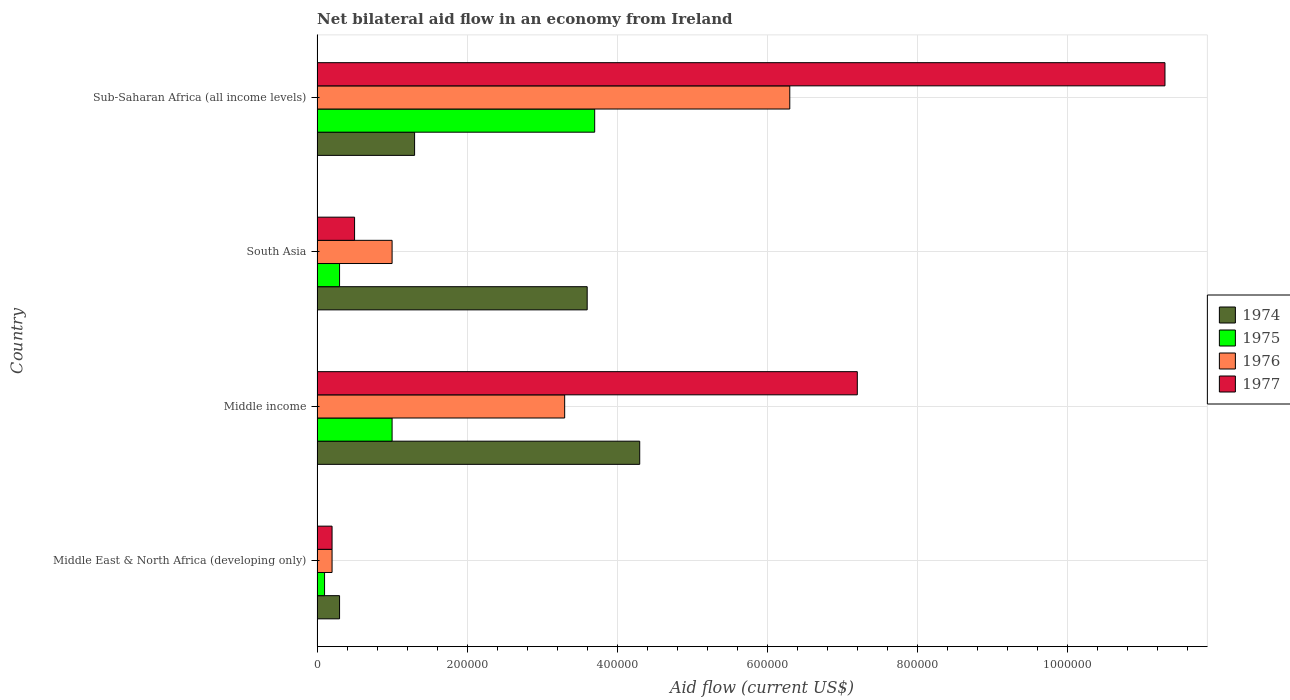How many different coloured bars are there?
Ensure brevity in your answer.  4. Are the number of bars per tick equal to the number of legend labels?
Your answer should be very brief. Yes. What is the label of the 4th group of bars from the top?
Offer a terse response. Middle East & North Africa (developing only). In how many cases, is the number of bars for a given country not equal to the number of legend labels?
Ensure brevity in your answer.  0. What is the net bilateral aid flow in 1977 in Sub-Saharan Africa (all income levels)?
Make the answer very short. 1.13e+06. In which country was the net bilateral aid flow in 1975 maximum?
Your response must be concise. Sub-Saharan Africa (all income levels). In which country was the net bilateral aid flow in 1977 minimum?
Keep it short and to the point. Middle East & North Africa (developing only). What is the total net bilateral aid flow in 1974 in the graph?
Make the answer very short. 9.50e+05. What is the difference between the net bilateral aid flow in 1977 in South Asia and that in Sub-Saharan Africa (all income levels)?
Your answer should be very brief. -1.08e+06. What is the difference between the net bilateral aid flow in 1976 in Sub-Saharan Africa (all income levels) and the net bilateral aid flow in 1974 in Middle income?
Give a very brief answer. 2.00e+05. What is the average net bilateral aid flow in 1976 per country?
Your response must be concise. 2.70e+05. In how many countries, is the net bilateral aid flow in 1977 greater than 840000 US$?
Make the answer very short. 1. What is the ratio of the net bilateral aid flow in 1976 in Middle East & North Africa (developing only) to that in South Asia?
Ensure brevity in your answer.  0.2. Is the difference between the net bilateral aid flow in 1975 in Middle income and Sub-Saharan Africa (all income levels) greater than the difference between the net bilateral aid flow in 1977 in Middle income and Sub-Saharan Africa (all income levels)?
Your response must be concise. Yes. Is it the case that in every country, the sum of the net bilateral aid flow in 1975 and net bilateral aid flow in 1976 is greater than the sum of net bilateral aid flow in 1974 and net bilateral aid flow in 1977?
Offer a terse response. No. What does the 2nd bar from the top in Middle East & North Africa (developing only) represents?
Provide a succinct answer. 1976. What does the 1st bar from the bottom in Sub-Saharan Africa (all income levels) represents?
Your answer should be compact. 1974. Is it the case that in every country, the sum of the net bilateral aid flow in 1975 and net bilateral aid flow in 1977 is greater than the net bilateral aid flow in 1976?
Your answer should be compact. No. Are all the bars in the graph horizontal?
Your answer should be very brief. Yes. How many countries are there in the graph?
Provide a succinct answer. 4. What is the difference between two consecutive major ticks on the X-axis?
Offer a terse response. 2.00e+05. Does the graph contain grids?
Ensure brevity in your answer.  Yes. Where does the legend appear in the graph?
Make the answer very short. Center right. What is the title of the graph?
Your answer should be compact. Net bilateral aid flow in an economy from Ireland. What is the label or title of the X-axis?
Your answer should be compact. Aid flow (current US$). What is the label or title of the Y-axis?
Offer a terse response. Country. What is the Aid flow (current US$) in 1974 in Middle East & North Africa (developing only)?
Make the answer very short. 3.00e+04. What is the Aid flow (current US$) in 1975 in Middle East & North Africa (developing only)?
Offer a terse response. 10000. What is the Aid flow (current US$) of 1976 in Middle East & North Africa (developing only)?
Give a very brief answer. 2.00e+04. What is the Aid flow (current US$) in 1977 in Middle income?
Your answer should be compact. 7.20e+05. What is the Aid flow (current US$) in 1975 in South Asia?
Your answer should be very brief. 3.00e+04. What is the Aid flow (current US$) of 1976 in Sub-Saharan Africa (all income levels)?
Offer a terse response. 6.30e+05. What is the Aid flow (current US$) in 1977 in Sub-Saharan Africa (all income levels)?
Your response must be concise. 1.13e+06. Across all countries, what is the maximum Aid flow (current US$) in 1975?
Offer a terse response. 3.70e+05. Across all countries, what is the maximum Aid flow (current US$) in 1976?
Your response must be concise. 6.30e+05. Across all countries, what is the maximum Aid flow (current US$) of 1977?
Your answer should be compact. 1.13e+06. Across all countries, what is the minimum Aid flow (current US$) in 1975?
Your response must be concise. 10000. Across all countries, what is the minimum Aid flow (current US$) in 1976?
Offer a terse response. 2.00e+04. Across all countries, what is the minimum Aid flow (current US$) of 1977?
Your response must be concise. 2.00e+04. What is the total Aid flow (current US$) in 1974 in the graph?
Provide a short and direct response. 9.50e+05. What is the total Aid flow (current US$) of 1975 in the graph?
Your response must be concise. 5.10e+05. What is the total Aid flow (current US$) of 1976 in the graph?
Give a very brief answer. 1.08e+06. What is the total Aid flow (current US$) in 1977 in the graph?
Keep it short and to the point. 1.92e+06. What is the difference between the Aid flow (current US$) in 1974 in Middle East & North Africa (developing only) and that in Middle income?
Your answer should be very brief. -4.00e+05. What is the difference between the Aid flow (current US$) of 1976 in Middle East & North Africa (developing only) and that in Middle income?
Ensure brevity in your answer.  -3.10e+05. What is the difference between the Aid flow (current US$) in 1977 in Middle East & North Africa (developing only) and that in Middle income?
Provide a short and direct response. -7.00e+05. What is the difference between the Aid flow (current US$) in 1974 in Middle East & North Africa (developing only) and that in South Asia?
Provide a short and direct response. -3.30e+05. What is the difference between the Aid flow (current US$) of 1974 in Middle East & North Africa (developing only) and that in Sub-Saharan Africa (all income levels)?
Your answer should be very brief. -1.00e+05. What is the difference between the Aid flow (current US$) of 1975 in Middle East & North Africa (developing only) and that in Sub-Saharan Africa (all income levels)?
Ensure brevity in your answer.  -3.60e+05. What is the difference between the Aid flow (current US$) in 1976 in Middle East & North Africa (developing only) and that in Sub-Saharan Africa (all income levels)?
Make the answer very short. -6.10e+05. What is the difference between the Aid flow (current US$) in 1977 in Middle East & North Africa (developing only) and that in Sub-Saharan Africa (all income levels)?
Your answer should be compact. -1.11e+06. What is the difference between the Aid flow (current US$) of 1975 in Middle income and that in South Asia?
Your answer should be very brief. 7.00e+04. What is the difference between the Aid flow (current US$) in 1976 in Middle income and that in South Asia?
Provide a short and direct response. 2.30e+05. What is the difference between the Aid flow (current US$) of 1977 in Middle income and that in South Asia?
Keep it short and to the point. 6.70e+05. What is the difference between the Aid flow (current US$) of 1975 in Middle income and that in Sub-Saharan Africa (all income levels)?
Make the answer very short. -2.70e+05. What is the difference between the Aid flow (current US$) in 1976 in Middle income and that in Sub-Saharan Africa (all income levels)?
Provide a short and direct response. -3.00e+05. What is the difference between the Aid flow (current US$) in 1977 in Middle income and that in Sub-Saharan Africa (all income levels)?
Give a very brief answer. -4.10e+05. What is the difference between the Aid flow (current US$) of 1976 in South Asia and that in Sub-Saharan Africa (all income levels)?
Your answer should be very brief. -5.30e+05. What is the difference between the Aid flow (current US$) in 1977 in South Asia and that in Sub-Saharan Africa (all income levels)?
Provide a short and direct response. -1.08e+06. What is the difference between the Aid flow (current US$) in 1974 in Middle East & North Africa (developing only) and the Aid flow (current US$) in 1976 in Middle income?
Your response must be concise. -3.00e+05. What is the difference between the Aid flow (current US$) of 1974 in Middle East & North Africa (developing only) and the Aid flow (current US$) of 1977 in Middle income?
Give a very brief answer. -6.90e+05. What is the difference between the Aid flow (current US$) of 1975 in Middle East & North Africa (developing only) and the Aid flow (current US$) of 1976 in Middle income?
Offer a very short reply. -3.20e+05. What is the difference between the Aid flow (current US$) in 1975 in Middle East & North Africa (developing only) and the Aid flow (current US$) in 1977 in Middle income?
Offer a very short reply. -7.10e+05. What is the difference between the Aid flow (current US$) in 1976 in Middle East & North Africa (developing only) and the Aid flow (current US$) in 1977 in Middle income?
Ensure brevity in your answer.  -7.00e+05. What is the difference between the Aid flow (current US$) of 1974 in Middle East & North Africa (developing only) and the Aid flow (current US$) of 1975 in South Asia?
Give a very brief answer. 0. What is the difference between the Aid flow (current US$) of 1974 in Middle East & North Africa (developing only) and the Aid flow (current US$) of 1977 in South Asia?
Provide a succinct answer. -2.00e+04. What is the difference between the Aid flow (current US$) in 1975 in Middle East & North Africa (developing only) and the Aid flow (current US$) in 1977 in South Asia?
Your answer should be compact. -4.00e+04. What is the difference between the Aid flow (current US$) in 1974 in Middle East & North Africa (developing only) and the Aid flow (current US$) in 1975 in Sub-Saharan Africa (all income levels)?
Your response must be concise. -3.40e+05. What is the difference between the Aid flow (current US$) in 1974 in Middle East & North Africa (developing only) and the Aid flow (current US$) in 1976 in Sub-Saharan Africa (all income levels)?
Offer a terse response. -6.00e+05. What is the difference between the Aid flow (current US$) in 1974 in Middle East & North Africa (developing only) and the Aid flow (current US$) in 1977 in Sub-Saharan Africa (all income levels)?
Give a very brief answer. -1.10e+06. What is the difference between the Aid flow (current US$) in 1975 in Middle East & North Africa (developing only) and the Aid flow (current US$) in 1976 in Sub-Saharan Africa (all income levels)?
Your answer should be very brief. -6.20e+05. What is the difference between the Aid flow (current US$) in 1975 in Middle East & North Africa (developing only) and the Aid flow (current US$) in 1977 in Sub-Saharan Africa (all income levels)?
Make the answer very short. -1.12e+06. What is the difference between the Aid flow (current US$) in 1976 in Middle East & North Africa (developing only) and the Aid flow (current US$) in 1977 in Sub-Saharan Africa (all income levels)?
Your answer should be very brief. -1.11e+06. What is the difference between the Aid flow (current US$) in 1974 in Middle income and the Aid flow (current US$) in 1975 in South Asia?
Your response must be concise. 4.00e+05. What is the difference between the Aid flow (current US$) of 1974 in Middle income and the Aid flow (current US$) of 1976 in South Asia?
Your response must be concise. 3.30e+05. What is the difference between the Aid flow (current US$) of 1974 in Middle income and the Aid flow (current US$) of 1977 in South Asia?
Offer a terse response. 3.80e+05. What is the difference between the Aid flow (current US$) of 1975 in Middle income and the Aid flow (current US$) of 1976 in South Asia?
Give a very brief answer. 0. What is the difference between the Aid flow (current US$) of 1975 in Middle income and the Aid flow (current US$) of 1977 in South Asia?
Provide a succinct answer. 5.00e+04. What is the difference between the Aid flow (current US$) in 1976 in Middle income and the Aid flow (current US$) in 1977 in South Asia?
Keep it short and to the point. 2.80e+05. What is the difference between the Aid flow (current US$) in 1974 in Middle income and the Aid flow (current US$) in 1977 in Sub-Saharan Africa (all income levels)?
Your answer should be very brief. -7.00e+05. What is the difference between the Aid flow (current US$) in 1975 in Middle income and the Aid flow (current US$) in 1976 in Sub-Saharan Africa (all income levels)?
Offer a very short reply. -5.30e+05. What is the difference between the Aid flow (current US$) in 1975 in Middle income and the Aid flow (current US$) in 1977 in Sub-Saharan Africa (all income levels)?
Make the answer very short. -1.03e+06. What is the difference between the Aid flow (current US$) of 1976 in Middle income and the Aid flow (current US$) of 1977 in Sub-Saharan Africa (all income levels)?
Ensure brevity in your answer.  -8.00e+05. What is the difference between the Aid flow (current US$) in 1974 in South Asia and the Aid flow (current US$) in 1975 in Sub-Saharan Africa (all income levels)?
Your answer should be compact. -10000. What is the difference between the Aid flow (current US$) in 1974 in South Asia and the Aid flow (current US$) in 1977 in Sub-Saharan Africa (all income levels)?
Make the answer very short. -7.70e+05. What is the difference between the Aid flow (current US$) of 1975 in South Asia and the Aid flow (current US$) of 1976 in Sub-Saharan Africa (all income levels)?
Offer a terse response. -6.00e+05. What is the difference between the Aid flow (current US$) of 1975 in South Asia and the Aid flow (current US$) of 1977 in Sub-Saharan Africa (all income levels)?
Make the answer very short. -1.10e+06. What is the difference between the Aid flow (current US$) of 1976 in South Asia and the Aid flow (current US$) of 1977 in Sub-Saharan Africa (all income levels)?
Your response must be concise. -1.03e+06. What is the average Aid flow (current US$) of 1974 per country?
Your answer should be compact. 2.38e+05. What is the average Aid flow (current US$) of 1975 per country?
Your answer should be compact. 1.28e+05. What is the average Aid flow (current US$) of 1976 per country?
Your answer should be very brief. 2.70e+05. What is the average Aid flow (current US$) of 1977 per country?
Ensure brevity in your answer.  4.80e+05. What is the difference between the Aid flow (current US$) of 1974 and Aid flow (current US$) of 1976 in Middle East & North Africa (developing only)?
Provide a succinct answer. 10000. What is the difference between the Aid flow (current US$) in 1974 and Aid flow (current US$) in 1977 in Middle East & North Africa (developing only)?
Provide a short and direct response. 10000. What is the difference between the Aid flow (current US$) in 1975 and Aid flow (current US$) in 1976 in Middle East & North Africa (developing only)?
Your answer should be very brief. -10000. What is the difference between the Aid flow (current US$) of 1975 and Aid flow (current US$) of 1977 in Middle East & North Africa (developing only)?
Your response must be concise. -10000. What is the difference between the Aid flow (current US$) in 1976 and Aid flow (current US$) in 1977 in Middle East & North Africa (developing only)?
Ensure brevity in your answer.  0. What is the difference between the Aid flow (current US$) of 1975 and Aid flow (current US$) of 1977 in Middle income?
Your answer should be very brief. -6.20e+05. What is the difference between the Aid flow (current US$) of 1976 and Aid flow (current US$) of 1977 in Middle income?
Make the answer very short. -3.90e+05. What is the difference between the Aid flow (current US$) in 1974 and Aid flow (current US$) in 1975 in South Asia?
Offer a very short reply. 3.30e+05. What is the difference between the Aid flow (current US$) of 1974 and Aid flow (current US$) of 1977 in South Asia?
Give a very brief answer. 3.10e+05. What is the difference between the Aid flow (current US$) in 1975 and Aid flow (current US$) in 1976 in South Asia?
Keep it short and to the point. -7.00e+04. What is the difference between the Aid flow (current US$) in 1975 and Aid flow (current US$) in 1977 in South Asia?
Provide a succinct answer. -2.00e+04. What is the difference between the Aid flow (current US$) of 1976 and Aid flow (current US$) of 1977 in South Asia?
Ensure brevity in your answer.  5.00e+04. What is the difference between the Aid flow (current US$) in 1974 and Aid flow (current US$) in 1975 in Sub-Saharan Africa (all income levels)?
Your answer should be compact. -2.40e+05. What is the difference between the Aid flow (current US$) in 1974 and Aid flow (current US$) in 1976 in Sub-Saharan Africa (all income levels)?
Make the answer very short. -5.00e+05. What is the difference between the Aid flow (current US$) in 1975 and Aid flow (current US$) in 1977 in Sub-Saharan Africa (all income levels)?
Your answer should be very brief. -7.60e+05. What is the difference between the Aid flow (current US$) of 1976 and Aid flow (current US$) of 1977 in Sub-Saharan Africa (all income levels)?
Keep it short and to the point. -5.00e+05. What is the ratio of the Aid flow (current US$) in 1974 in Middle East & North Africa (developing only) to that in Middle income?
Offer a terse response. 0.07. What is the ratio of the Aid flow (current US$) in 1975 in Middle East & North Africa (developing only) to that in Middle income?
Your answer should be very brief. 0.1. What is the ratio of the Aid flow (current US$) of 1976 in Middle East & North Africa (developing only) to that in Middle income?
Your answer should be very brief. 0.06. What is the ratio of the Aid flow (current US$) of 1977 in Middle East & North Africa (developing only) to that in Middle income?
Your answer should be compact. 0.03. What is the ratio of the Aid flow (current US$) in 1974 in Middle East & North Africa (developing only) to that in South Asia?
Your answer should be compact. 0.08. What is the ratio of the Aid flow (current US$) of 1975 in Middle East & North Africa (developing only) to that in South Asia?
Your answer should be very brief. 0.33. What is the ratio of the Aid flow (current US$) of 1976 in Middle East & North Africa (developing only) to that in South Asia?
Ensure brevity in your answer.  0.2. What is the ratio of the Aid flow (current US$) in 1977 in Middle East & North Africa (developing only) to that in South Asia?
Give a very brief answer. 0.4. What is the ratio of the Aid flow (current US$) of 1974 in Middle East & North Africa (developing only) to that in Sub-Saharan Africa (all income levels)?
Offer a very short reply. 0.23. What is the ratio of the Aid flow (current US$) of 1975 in Middle East & North Africa (developing only) to that in Sub-Saharan Africa (all income levels)?
Provide a succinct answer. 0.03. What is the ratio of the Aid flow (current US$) in 1976 in Middle East & North Africa (developing only) to that in Sub-Saharan Africa (all income levels)?
Your response must be concise. 0.03. What is the ratio of the Aid flow (current US$) of 1977 in Middle East & North Africa (developing only) to that in Sub-Saharan Africa (all income levels)?
Make the answer very short. 0.02. What is the ratio of the Aid flow (current US$) of 1974 in Middle income to that in South Asia?
Your answer should be very brief. 1.19. What is the ratio of the Aid flow (current US$) of 1977 in Middle income to that in South Asia?
Offer a very short reply. 14.4. What is the ratio of the Aid flow (current US$) in 1974 in Middle income to that in Sub-Saharan Africa (all income levels)?
Your response must be concise. 3.31. What is the ratio of the Aid flow (current US$) of 1975 in Middle income to that in Sub-Saharan Africa (all income levels)?
Offer a very short reply. 0.27. What is the ratio of the Aid flow (current US$) of 1976 in Middle income to that in Sub-Saharan Africa (all income levels)?
Make the answer very short. 0.52. What is the ratio of the Aid flow (current US$) in 1977 in Middle income to that in Sub-Saharan Africa (all income levels)?
Give a very brief answer. 0.64. What is the ratio of the Aid flow (current US$) in 1974 in South Asia to that in Sub-Saharan Africa (all income levels)?
Offer a terse response. 2.77. What is the ratio of the Aid flow (current US$) of 1975 in South Asia to that in Sub-Saharan Africa (all income levels)?
Keep it short and to the point. 0.08. What is the ratio of the Aid flow (current US$) of 1976 in South Asia to that in Sub-Saharan Africa (all income levels)?
Provide a succinct answer. 0.16. What is the ratio of the Aid flow (current US$) in 1977 in South Asia to that in Sub-Saharan Africa (all income levels)?
Your answer should be compact. 0.04. What is the difference between the highest and the second highest Aid flow (current US$) in 1975?
Your answer should be compact. 2.70e+05. What is the difference between the highest and the second highest Aid flow (current US$) of 1977?
Give a very brief answer. 4.10e+05. What is the difference between the highest and the lowest Aid flow (current US$) in 1974?
Provide a short and direct response. 4.00e+05. What is the difference between the highest and the lowest Aid flow (current US$) of 1975?
Your answer should be very brief. 3.60e+05. What is the difference between the highest and the lowest Aid flow (current US$) of 1977?
Ensure brevity in your answer.  1.11e+06. 